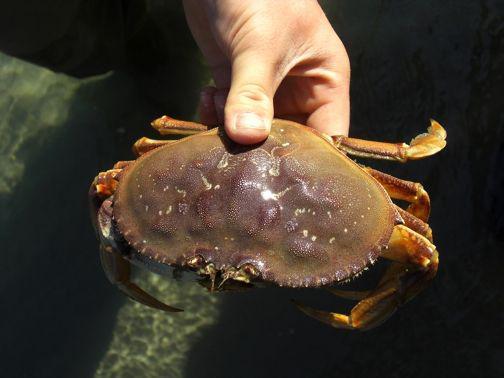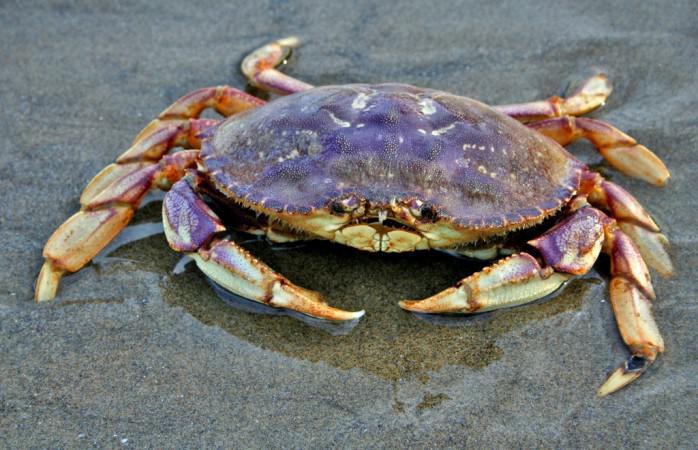The first image is the image on the left, the second image is the image on the right. Assess this claim about the two images: "One of the crabs is a shade of purple, the other is a shade of brown.". Correct or not? Answer yes or no. Yes. The first image is the image on the left, the second image is the image on the right. For the images shown, is this caption "The left and right image contains the same number of crabs in the sand." true? Answer yes or no. No. 